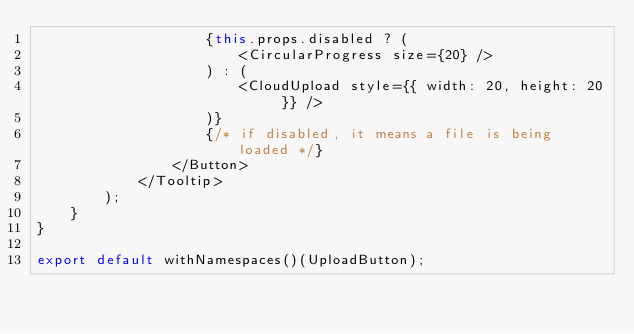Convert code to text. <code><loc_0><loc_0><loc_500><loc_500><_JavaScript_>                    {this.props.disabled ? (
                        <CircularProgress size={20} />
                    ) : (
                        <CloudUpload style={{ width: 20, height: 20 }} />
                    )}
                    {/* if disabled, it means a file is being loaded */}
                </Button>
            </Tooltip>
        );
    }
}

export default withNamespaces()(UploadButton);
</code> 